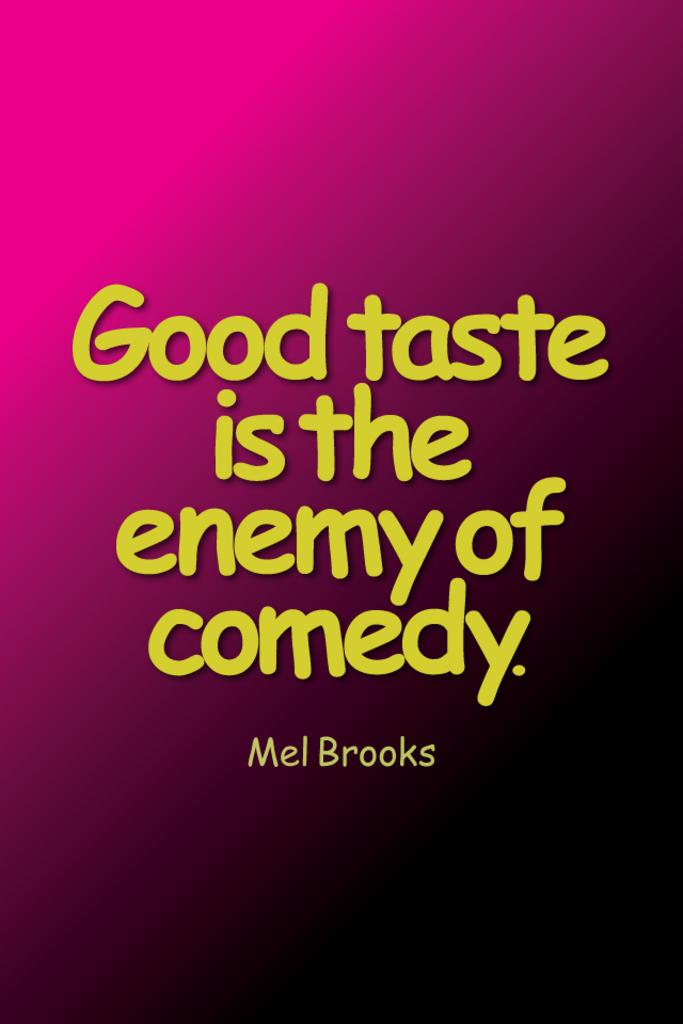<image>
Give a short and clear explanation of the subsequent image. A text quote by Mel brooks on a pink gradient background which reads: "Good taste is the enemy of comedy" 